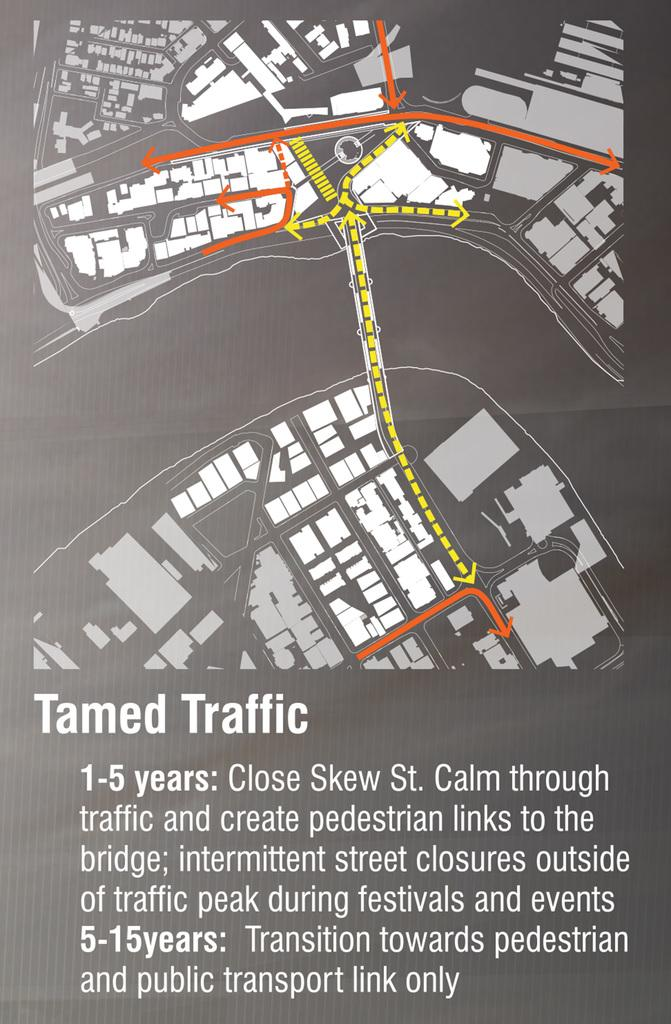<image>
Provide a brief description of the given image. A map of traffic in the Tamed area with information from 1-5 years and 5-15 years. 